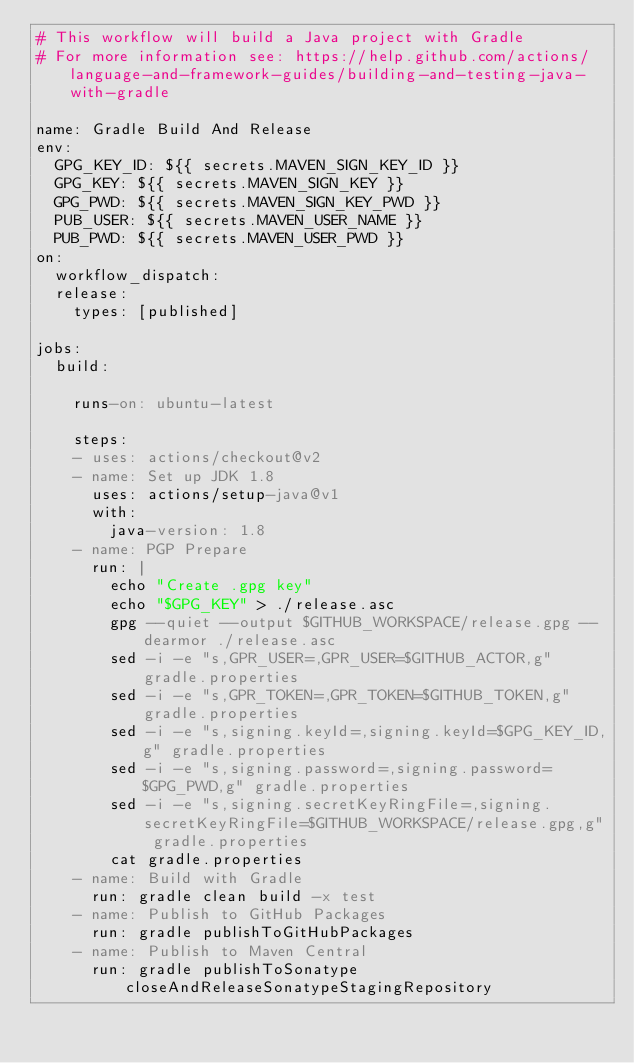Convert code to text. <code><loc_0><loc_0><loc_500><loc_500><_YAML_># This workflow will build a Java project with Gradle
# For more information see: https://help.github.com/actions/language-and-framework-guides/building-and-testing-java-with-gradle

name: Gradle Build And Release
env:
  GPG_KEY_ID: ${{ secrets.MAVEN_SIGN_KEY_ID }}
  GPG_KEY: ${{ secrets.MAVEN_SIGN_KEY }}
  GPG_PWD: ${{ secrets.MAVEN_SIGN_KEY_PWD }}
  PUB_USER: ${{ secrets.MAVEN_USER_NAME }}
  PUB_PWD: ${{ secrets.MAVEN_USER_PWD }}
on:
  workflow_dispatch:
  release:
    types: [published]

jobs:
  build:

    runs-on: ubuntu-latest

    steps:
    - uses: actions/checkout@v2
    - name: Set up JDK 1.8
      uses: actions/setup-java@v1
      with:
        java-version: 1.8
    - name: PGP Prepare
      run: |
        echo "Create .gpg key"
        echo "$GPG_KEY" > ./release.asc
        gpg --quiet --output $GITHUB_WORKSPACE/release.gpg --dearmor ./release.asc
        sed -i -e "s,GPR_USER=,GPR_USER=$GITHUB_ACTOR,g" gradle.properties
        sed -i -e "s,GPR_TOKEN=,GPR_TOKEN=$GITHUB_TOKEN,g" gradle.properties
        sed -i -e "s,signing.keyId=,signing.keyId=$GPG_KEY_ID,g" gradle.properties
        sed -i -e "s,signing.password=,signing.password=$GPG_PWD,g" gradle.properties
        sed -i -e "s,signing.secretKeyRingFile=,signing.secretKeyRingFile=$GITHUB_WORKSPACE/release.gpg,g" gradle.properties
        cat gradle.properties
    - name: Build with Gradle
      run: gradle clean build -x test
    - name: Publish to GitHub Packages
      run: gradle publishToGitHubPackages
    - name: Publish to Maven Central
      run: gradle publishToSonatype closeAndReleaseSonatypeStagingRepository</code> 